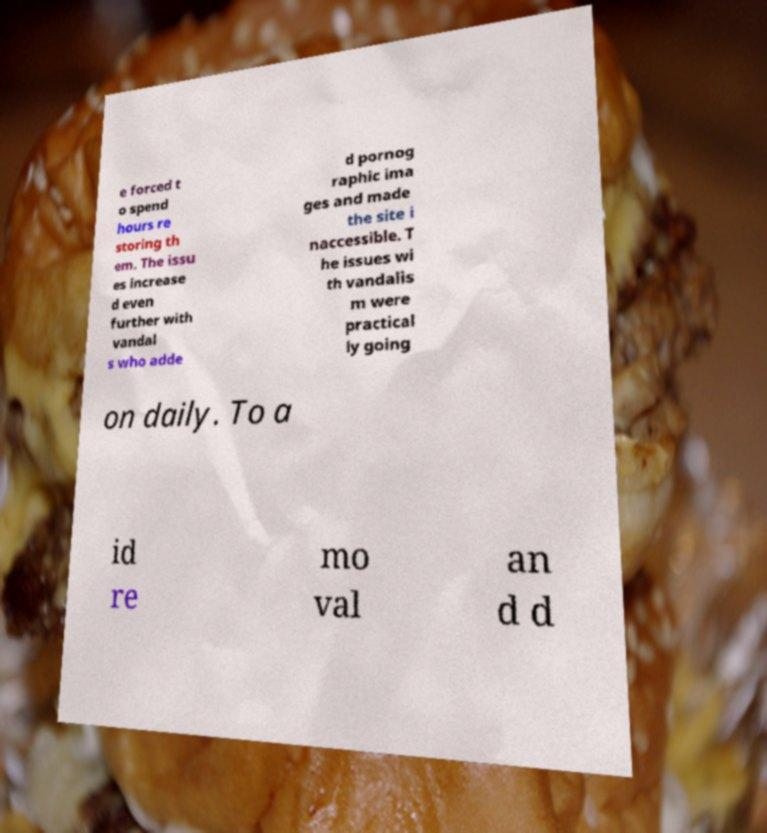Please read and relay the text visible in this image. What does it say? e forced t o spend hours re storing th em. The issu es increase d even further with vandal s who adde d pornog raphic ima ges and made the site i naccessible. T he issues wi th vandalis m were practical ly going on daily. To a id re mo val an d d 